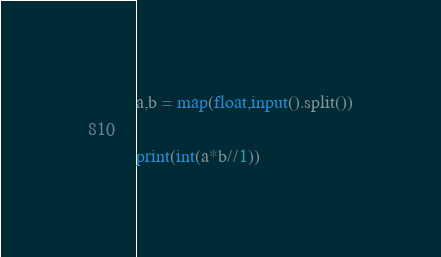Convert code to text. <code><loc_0><loc_0><loc_500><loc_500><_Python_>a,b = map(float,input().split())

print(int(a*b//1))</code> 